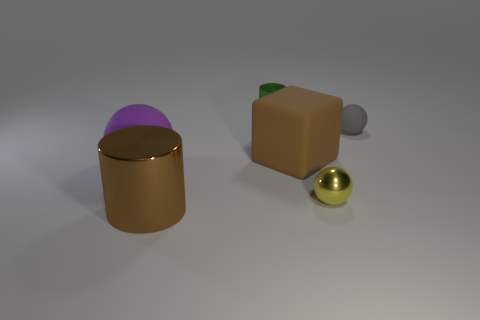Add 3 yellow objects. How many objects exist? 9 Subtract all cylinders. How many objects are left? 4 Add 3 yellow spheres. How many yellow spheres exist? 4 Subtract 0 brown spheres. How many objects are left? 6 Subtract all yellow cylinders. Subtract all small green cylinders. How many objects are left? 5 Add 4 rubber balls. How many rubber balls are left? 6 